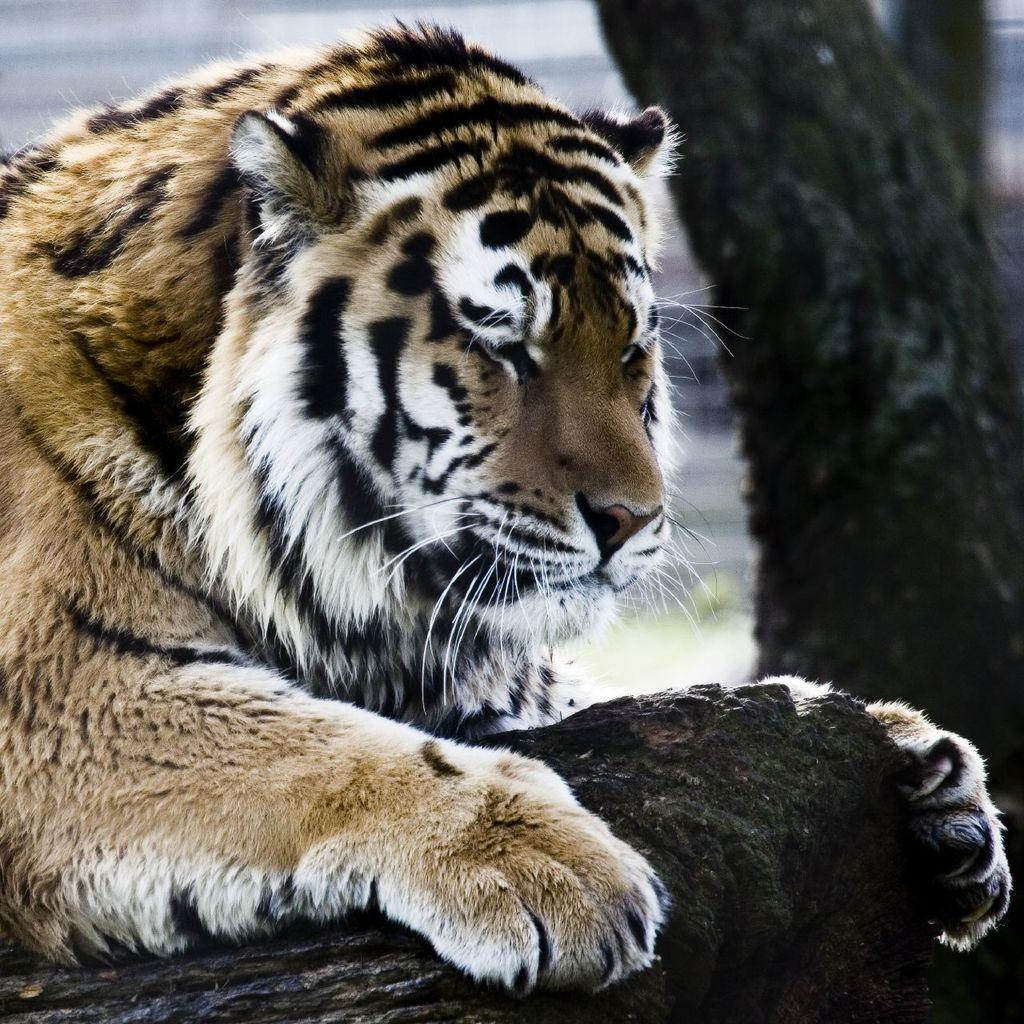What animal is present in the image? There is a tiger in the image. What object can be seen alongside the tiger? There is a wooden log in the image. Can you describe the background of the image? The background of the image is blurred. What type of news can be heard coming from the tiger in the image? There is no indication in the image that the tiger is making any sounds or delivering news. 